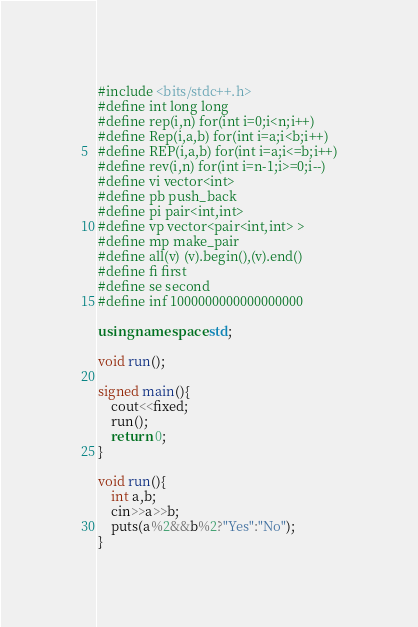Convert code to text. <code><loc_0><loc_0><loc_500><loc_500><_C++_>#include <bits/stdc++.h>
#define int long long
#define rep(i,n) for(int i=0;i<n;i++)
#define Rep(i,a,b) for(int i=a;i<b;i++)
#define REP(i,a,b) for(int i=a;i<=b;i++)
#define rev(i,n) for(int i=n-1;i>=0;i--)
#define vi vector<int>
#define pb push_back
#define pi pair<int,int>
#define vp vector<pair<int,int> >
#define mp make_pair
#define all(v) (v).begin(),(v).end()
#define fi first
#define se second
#define inf 1000000000000000000

using namespace std;

void run();

signed main(){
    cout<<fixed;
    run();
    return 0;
}

void run(){
    int a,b;
    cin>>a>>b;
    puts(a%2&&b%2?"Yes":"No");
}</code> 